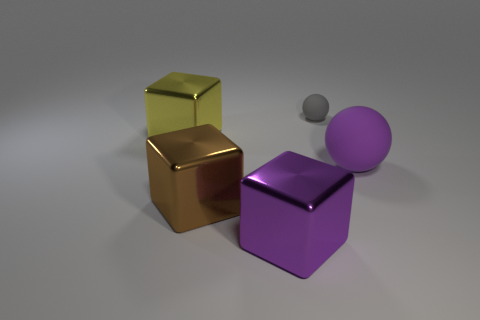Add 5 big purple matte objects. How many objects exist? 10 Subtract all cubes. How many objects are left? 2 Subtract all large gray spheres. Subtract all gray matte things. How many objects are left? 4 Add 1 tiny gray objects. How many tiny gray objects are left? 2 Add 1 gray things. How many gray things exist? 2 Subtract 0 blue spheres. How many objects are left? 5 